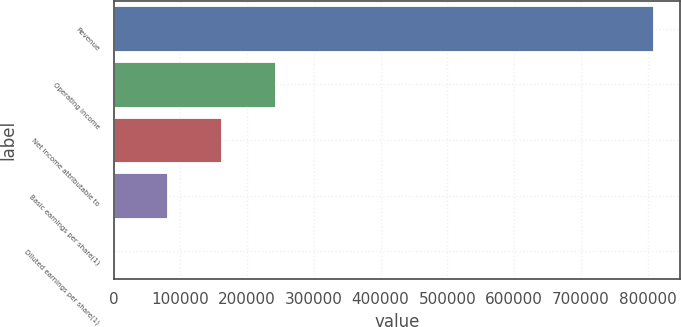<chart> <loc_0><loc_0><loc_500><loc_500><bar_chart><fcel>Revenue<fcel>Operating income<fcel>Net income attributable to<fcel>Basic earnings per share(1)<fcel>Diluted earnings per share(1)<nl><fcel>808370<fcel>242511<fcel>161674<fcel>80837.2<fcel>0.25<nl></chart> 